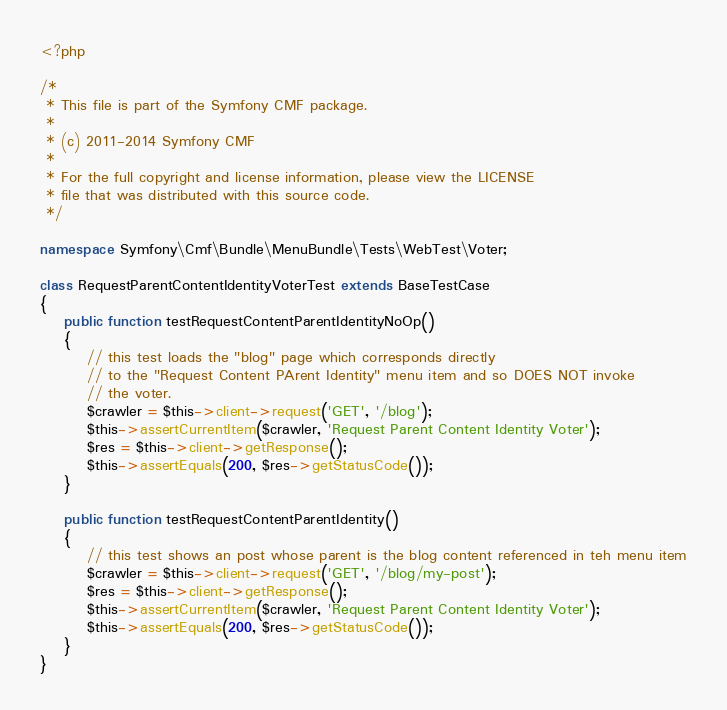<code> <loc_0><loc_0><loc_500><loc_500><_PHP_><?php

/*
 * This file is part of the Symfony CMF package.
 *
 * (c) 2011-2014 Symfony CMF
 *
 * For the full copyright and license information, please view the LICENSE
 * file that was distributed with this source code.
 */

namespace Symfony\Cmf\Bundle\MenuBundle\Tests\WebTest\Voter;

class RequestParentContentIdentityVoterTest extends BaseTestCase
{
    public function testRequestContentParentIdentityNoOp()
    {
        // this test loads the "blog" page which corresponds directly
        // to the "Request Content PArent Identity" menu item and so DOES NOT invoke
        // the voter.
        $crawler = $this->client->request('GET', '/blog');
        $this->assertCurrentItem($crawler, 'Request Parent Content Identity Voter');
        $res = $this->client->getResponse();
        $this->assertEquals(200, $res->getStatusCode());
    }

    public function testRequestContentParentIdentity()
    {
        // this test shows an post whose parent is the blog content referenced in teh menu item
        $crawler = $this->client->request('GET', '/blog/my-post');
        $res = $this->client->getResponse();
        $this->assertCurrentItem($crawler, 'Request Parent Content Identity Voter');
        $this->assertEquals(200, $res->getStatusCode());
    }
}
</code> 